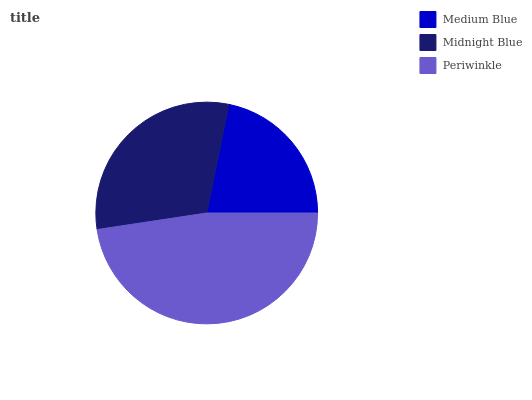Is Medium Blue the minimum?
Answer yes or no. Yes. Is Periwinkle the maximum?
Answer yes or no. Yes. Is Midnight Blue the minimum?
Answer yes or no. No. Is Midnight Blue the maximum?
Answer yes or no. No. Is Midnight Blue greater than Medium Blue?
Answer yes or no. Yes. Is Medium Blue less than Midnight Blue?
Answer yes or no. Yes. Is Medium Blue greater than Midnight Blue?
Answer yes or no. No. Is Midnight Blue less than Medium Blue?
Answer yes or no. No. Is Midnight Blue the high median?
Answer yes or no. Yes. Is Midnight Blue the low median?
Answer yes or no. Yes. Is Medium Blue the high median?
Answer yes or no. No. Is Periwinkle the low median?
Answer yes or no. No. 